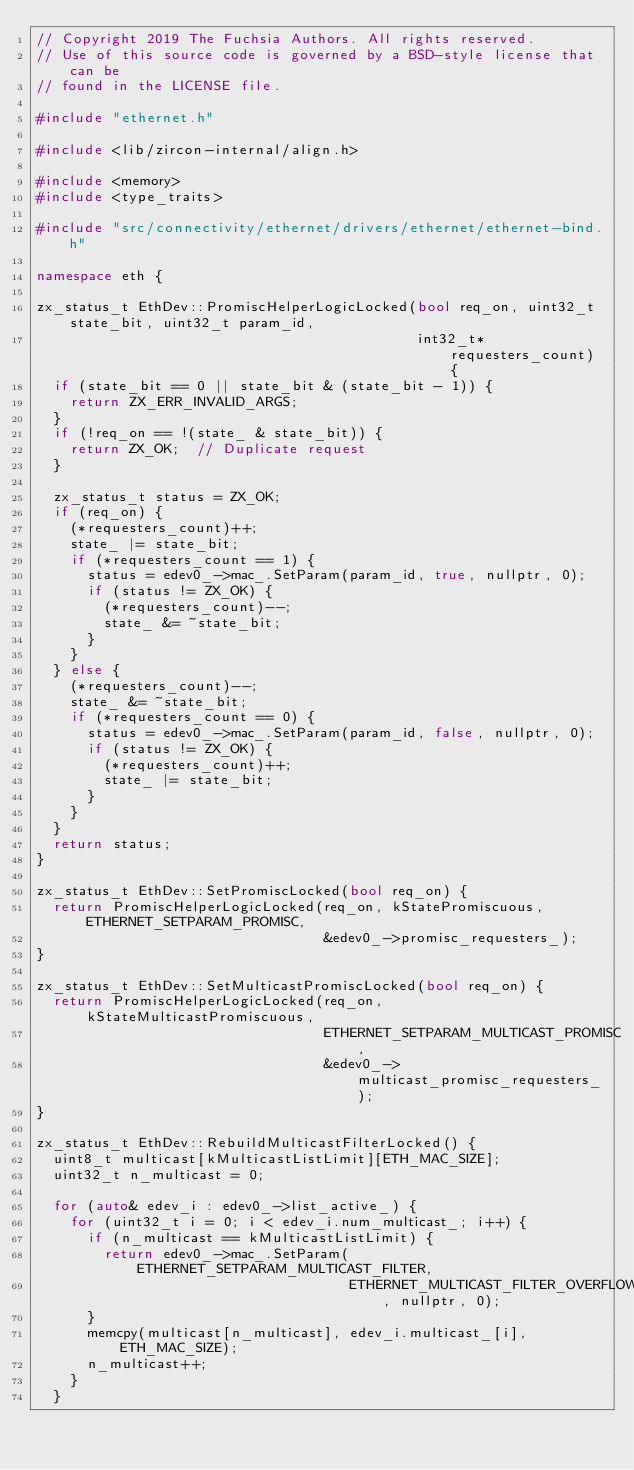Convert code to text. <code><loc_0><loc_0><loc_500><loc_500><_C++_>// Copyright 2019 The Fuchsia Authors. All rights reserved.
// Use of this source code is governed by a BSD-style license that can be
// found in the LICENSE file.

#include "ethernet.h"

#include <lib/zircon-internal/align.h>

#include <memory>
#include <type_traits>

#include "src/connectivity/ethernet/drivers/ethernet/ethernet-bind.h"

namespace eth {

zx_status_t EthDev::PromiscHelperLogicLocked(bool req_on, uint32_t state_bit, uint32_t param_id,
                                             int32_t* requesters_count) {
  if (state_bit == 0 || state_bit & (state_bit - 1)) {
    return ZX_ERR_INVALID_ARGS;
  }
  if (!req_on == !(state_ & state_bit)) {
    return ZX_OK;  // Duplicate request
  }

  zx_status_t status = ZX_OK;
  if (req_on) {
    (*requesters_count)++;
    state_ |= state_bit;
    if (*requesters_count == 1) {
      status = edev0_->mac_.SetParam(param_id, true, nullptr, 0);
      if (status != ZX_OK) {
        (*requesters_count)--;
        state_ &= ~state_bit;
      }
    }
  } else {
    (*requesters_count)--;
    state_ &= ~state_bit;
    if (*requesters_count == 0) {
      status = edev0_->mac_.SetParam(param_id, false, nullptr, 0);
      if (status != ZX_OK) {
        (*requesters_count)++;
        state_ |= state_bit;
      }
    }
  }
  return status;
}

zx_status_t EthDev::SetPromiscLocked(bool req_on) {
  return PromiscHelperLogicLocked(req_on, kStatePromiscuous, ETHERNET_SETPARAM_PROMISC,
                                  &edev0_->promisc_requesters_);
}

zx_status_t EthDev::SetMulticastPromiscLocked(bool req_on) {
  return PromiscHelperLogicLocked(req_on, kStateMulticastPromiscuous,
                                  ETHERNET_SETPARAM_MULTICAST_PROMISC,
                                  &edev0_->multicast_promisc_requesters_);
}

zx_status_t EthDev::RebuildMulticastFilterLocked() {
  uint8_t multicast[kMulticastListLimit][ETH_MAC_SIZE];
  uint32_t n_multicast = 0;

  for (auto& edev_i : edev0_->list_active_) {
    for (uint32_t i = 0; i < edev_i.num_multicast_; i++) {
      if (n_multicast == kMulticastListLimit) {
        return edev0_->mac_.SetParam(ETHERNET_SETPARAM_MULTICAST_FILTER,
                                     ETHERNET_MULTICAST_FILTER_OVERFLOW, nullptr, 0);
      }
      memcpy(multicast[n_multicast], edev_i.multicast_[i], ETH_MAC_SIZE);
      n_multicast++;
    }
  }</code> 